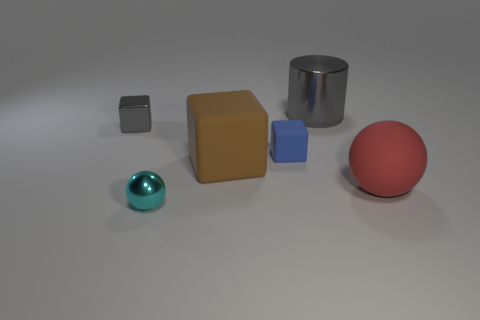The small rubber thing has what color?
Your answer should be very brief. Blue. Do the thing that is on the right side of the gray cylinder and the large cylinder have the same size?
Offer a terse response. Yes. The ball in front of the matte object to the right of the gray thing behind the metallic block is made of what material?
Provide a succinct answer. Metal. Do the tiny block on the right side of the small cyan metallic thing and the small object that is on the left side of the small cyan metallic object have the same color?
Ensure brevity in your answer.  No. There is a tiny cube right of the gray metallic thing in front of the shiny cylinder; what is its material?
Your answer should be very brief. Rubber. What color is the shiny sphere that is the same size as the gray cube?
Your response must be concise. Cyan. Do the tiny blue object and the gray metallic thing to the right of the tiny cyan sphere have the same shape?
Your answer should be very brief. No. There is a metal thing that is the same color as the shiny cylinder; what shape is it?
Make the answer very short. Cube. What number of big things are behind the large red rubber object that is on the right side of the object left of the cyan ball?
Your answer should be compact. 2. What size is the rubber object that is on the right side of the gray object on the right side of the tiny cyan metal object?
Give a very brief answer. Large. 